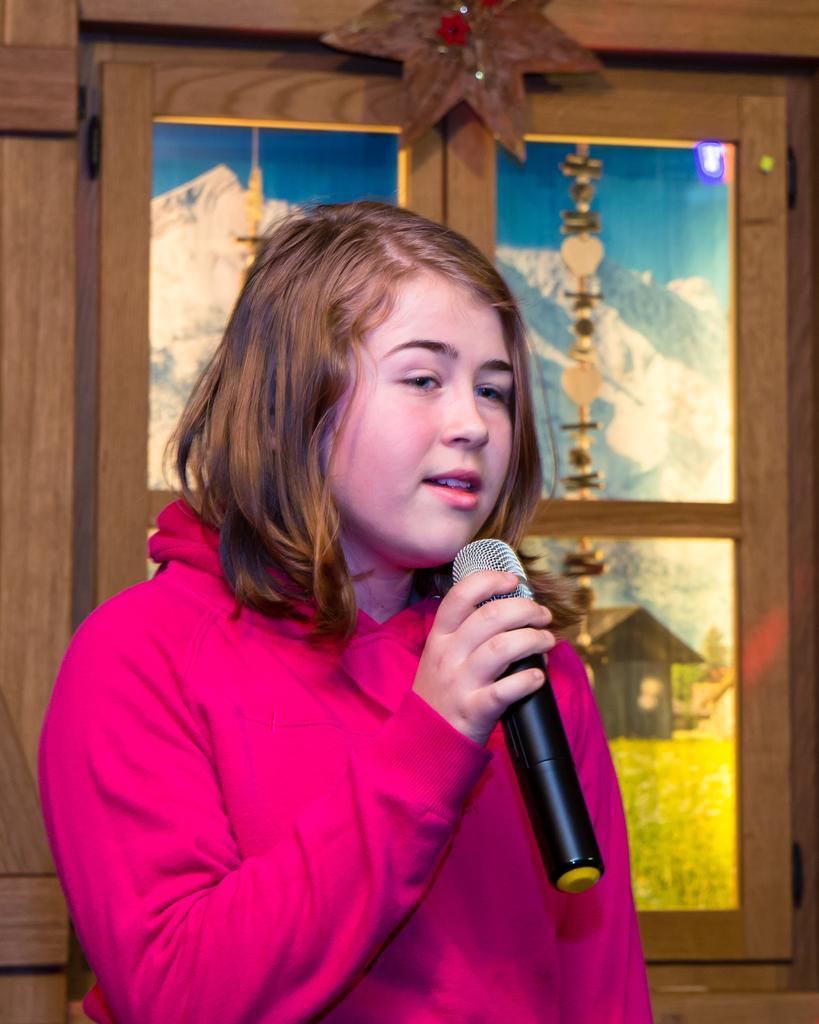What is the main subject of the image? There is a person in the image. What can be observed about the person's attire? The person is wearing clothes. What is the person holding in her hand? The person is holding a mic with her hand. What architectural feature is visible in the image? There is a window visible in the image. What type of debt is the person discussing in the image? There is no indication of a debt or any discussion about it in the image. What kind of haircut does the person have in the image? The image does not show the person's haircut, as it focuses on the person holding a mic. 